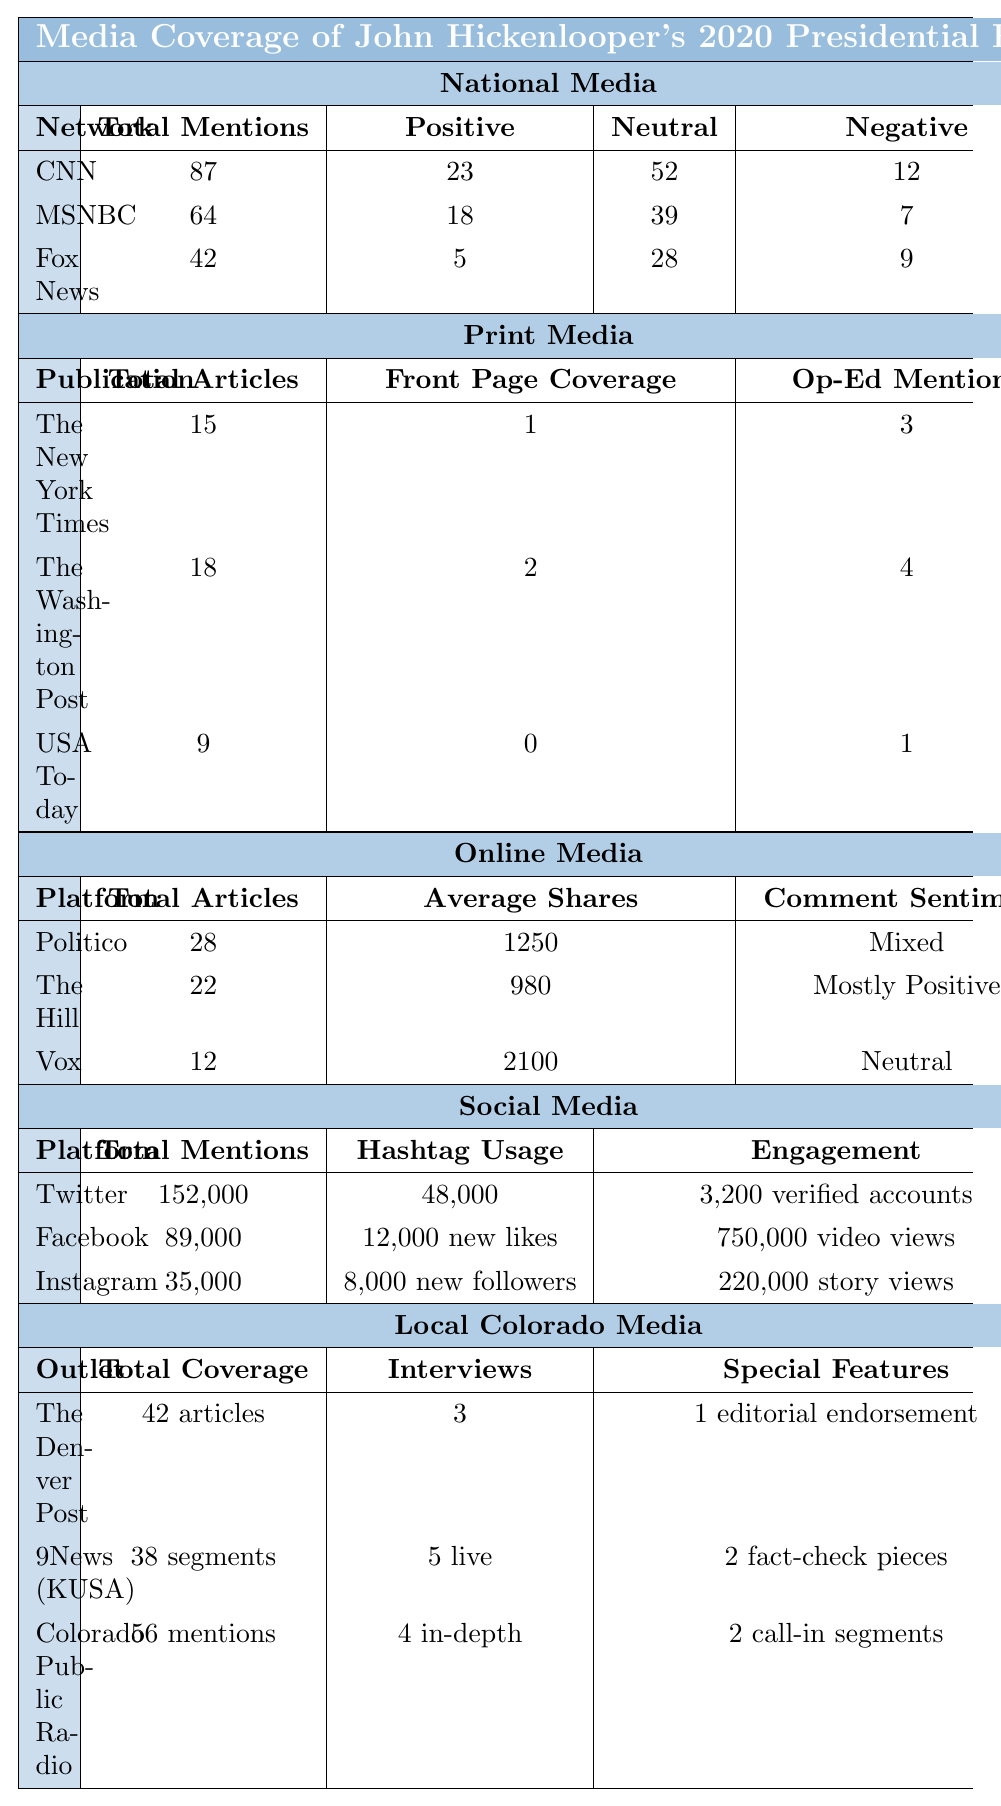What is the total number of mentions for CNN during Hickenlooper's presidential run? The table lists CNN under National Media with a "Total Mentions" value of 87.
Answer: 87 How many total articles did The New York Times publish regarding Hickenlooper? The table shows that The New York Times published a total of 15 articles.
Answer: 15 Which media platform had the highest average shares? By comparing the "Average Shares" across the Online Media section, Vox has the highest value at 2100.
Answer: Vox What percent of Fox News coverage was neutral? Fox News had 42 total mentions, with 28 being neutral. The percentage of neutral coverage is calculated as (28/42)*100 = 66.67%.
Answer: 66.67% Did the social media platform Facebook have more mentions than Instagram? The total mentions for Facebook are 89,000, while Instagram has 35,000 mentions, indicating that Facebook had more mentions.
Answer: Yes What is the total number of articles published by both The Washington Post and USA Today? The table states that The Washington Post published 18 articles and USA Today published 9 articles. Adding these values gives 18 + 9 = 27.
Answer: 27 How many live interviews were conducted by 9News (KUSA)? According to the table, 9News (KUSA) conducted 5 live interviews.
Answer: 5 Which media outlet had the least positive coverage? To find the outlet with the least positive coverage, we look at the National Media section; Fox News had the lowest positive coverage with only 5 mentions.
Answer: Fox News What is the total number of mentions across all social media platforms? Adding all the mentions from social media: Twitter (152,000) + Facebook (89,000) + Instagram (35,000) gives a total of 276,000 mentions.
Answer: 276,000 How does the total number of articles from Politico compare to the total from The Hill? Politico has 28 articles, and The Hill has 22 articles. Therefore, Politico has more articles than The Hill.
Answer: Yes 